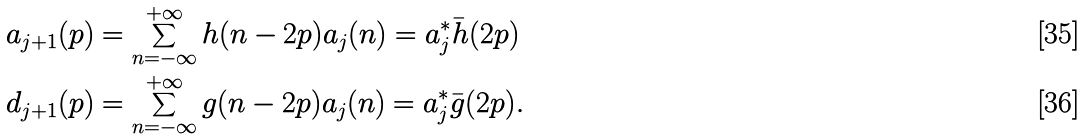<formula> <loc_0><loc_0><loc_500><loc_500>a _ { j + 1 } ( p ) & = \sum _ { n = - \infty } ^ { + \infty } h ( n - 2 p ) a _ { j } ( n ) = a _ { j } ^ { * } \bar { h } ( 2 p ) \\ d _ { j + 1 } ( p ) & = \sum _ { n = - \infty } ^ { + \infty } g ( n - 2 p ) a _ { j } ( n ) = a _ { j } ^ { * } \bar { g } ( 2 p ) .</formula> 